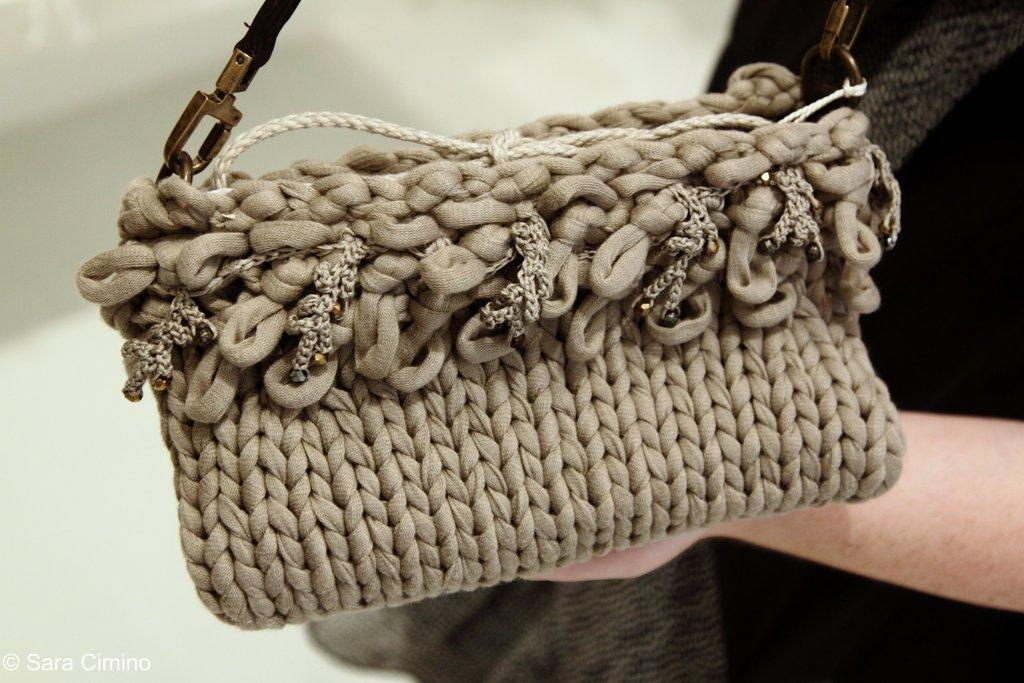What object is in the image that people often carry? There is a handbag in the image. What color is the handbag? The handbag is cream in color. Does the handbag have a feature that allows it to be carried on the shoulder? Yes, the handbag has a strap. Who is holding the handbag in the image? A person is holding the handbag in their hands. How many chickens are visible in the image? There are no chickens present in the image. Can you describe the copy on the handbag in the image? There is no copy or text visible on the handbag in the image. 